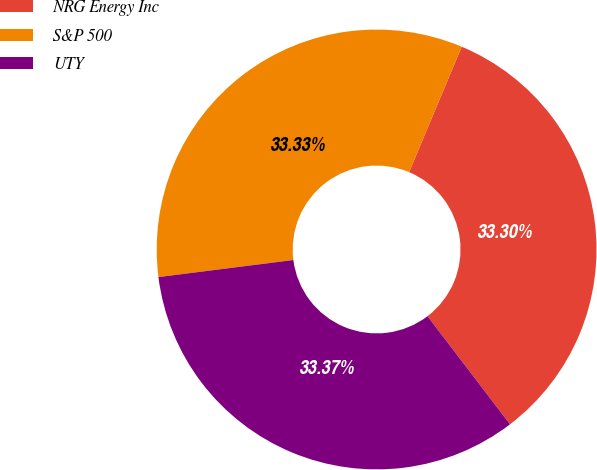<chart> <loc_0><loc_0><loc_500><loc_500><pie_chart><fcel>NRG Energy Inc<fcel>S&P 500<fcel>UTY<nl><fcel>33.3%<fcel>33.33%<fcel>33.37%<nl></chart> 